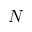<formula> <loc_0><loc_0><loc_500><loc_500>N</formula> 